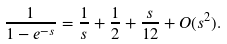Convert formula to latex. <formula><loc_0><loc_0><loc_500><loc_500>\frac { 1 } { 1 - e ^ { - s } } = \frac { 1 } { s } + \frac { 1 } { 2 } + \frac { s } { 1 2 } + O ( s ^ { 2 } ) .</formula> 